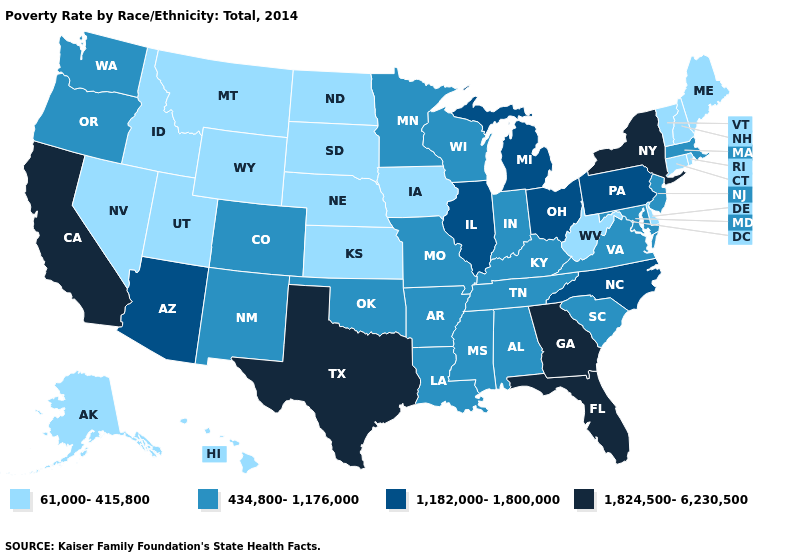Name the states that have a value in the range 434,800-1,176,000?
Short answer required. Alabama, Arkansas, Colorado, Indiana, Kentucky, Louisiana, Maryland, Massachusetts, Minnesota, Mississippi, Missouri, New Jersey, New Mexico, Oklahoma, Oregon, South Carolina, Tennessee, Virginia, Washington, Wisconsin. How many symbols are there in the legend?
Be succinct. 4. Name the states that have a value in the range 1,824,500-6,230,500?
Answer briefly. California, Florida, Georgia, New York, Texas. Does Alabama have the lowest value in the USA?
Quick response, please. No. Does Indiana have the lowest value in the USA?
Short answer required. No. What is the highest value in states that border North Carolina?
Give a very brief answer. 1,824,500-6,230,500. Name the states that have a value in the range 434,800-1,176,000?
Be succinct. Alabama, Arkansas, Colorado, Indiana, Kentucky, Louisiana, Maryland, Massachusetts, Minnesota, Mississippi, Missouri, New Jersey, New Mexico, Oklahoma, Oregon, South Carolina, Tennessee, Virginia, Washington, Wisconsin. What is the value of Kansas?
Keep it brief. 61,000-415,800. What is the value of Colorado?
Keep it brief. 434,800-1,176,000. What is the lowest value in the USA?
Write a very short answer. 61,000-415,800. What is the highest value in the USA?
Give a very brief answer. 1,824,500-6,230,500. Among the states that border New Mexico , does Utah have the lowest value?
Quick response, please. Yes. Name the states that have a value in the range 1,182,000-1,800,000?
Answer briefly. Arizona, Illinois, Michigan, North Carolina, Ohio, Pennsylvania. How many symbols are there in the legend?
Quick response, please. 4. What is the value of North Dakota?
Keep it brief. 61,000-415,800. 